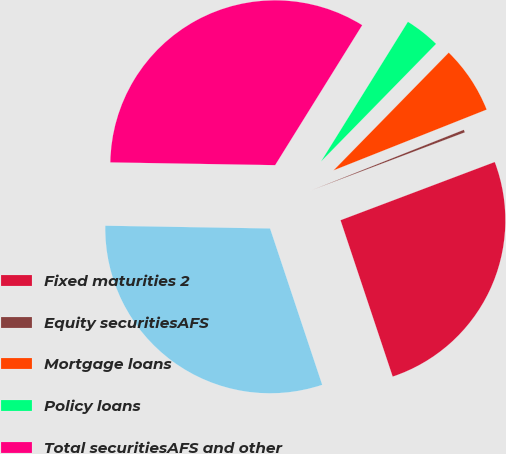Convert chart to OTSL. <chart><loc_0><loc_0><loc_500><loc_500><pie_chart><fcel>Fixed maturities 2<fcel>Equity securitiesAFS<fcel>Mortgage loans<fcel>Policy loans<fcel>Total securitiesAFS and other<fcel>Total securities AFS and other<nl><fcel>25.62%<fcel>0.27%<fcel>6.66%<fcel>3.47%<fcel>33.59%<fcel>30.39%<nl></chart> 